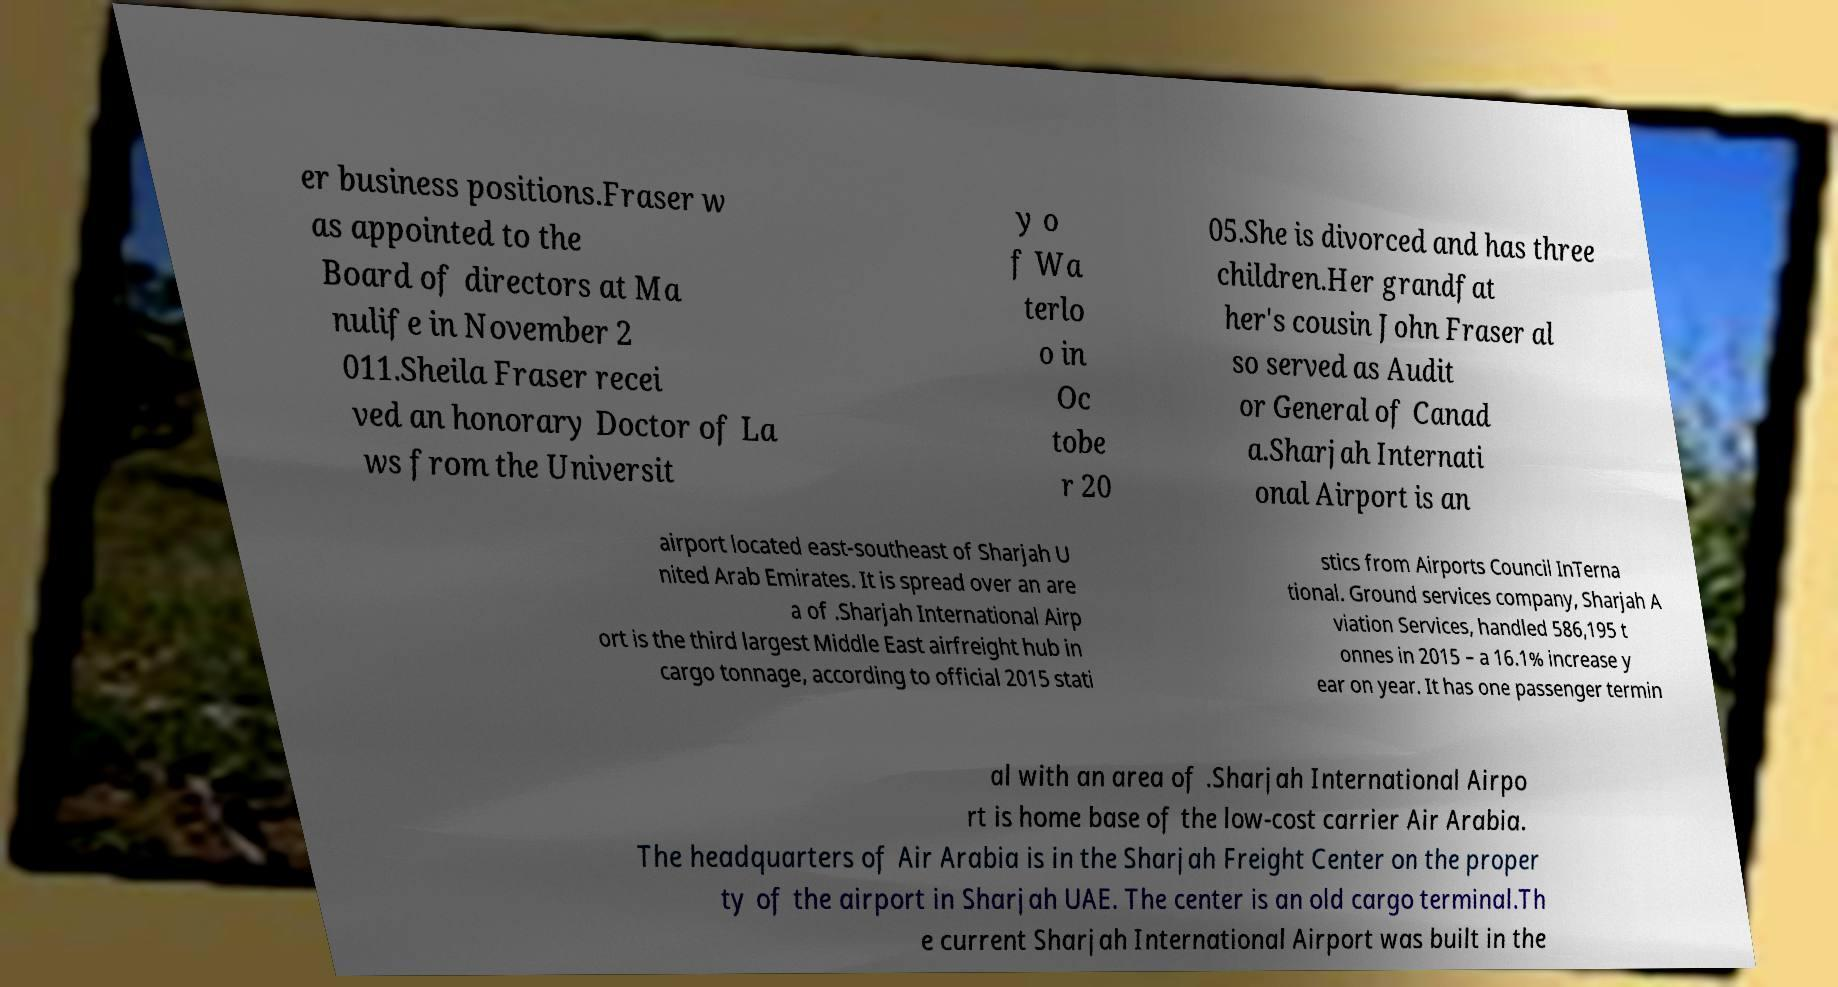Can you read and provide the text displayed in the image?This photo seems to have some interesting text. Can you extract and type it out for me? er business positions.Fraser w as appointed to the Board of directors at Ma nulife in November 2 011.Sheila Fraser recei ved an honorary Doctor of La ws from the Universit y o f Wa terlo o in Oc tobe r 20 05.She is divorced and has three children.Her grandfat her's cousin John Fraser al so served as Audit or General of Canad a.Sharjah Internati onal Airport is an airport located east-southeast of Sharjah U nited Arab Emirates. It is spread over an are a of .Sharjah International Airp ort is the third largest Middle East airfreight hub in cargo tonnage, according to official 2015 stati stics from Airports Council InTerna tional. Ground services company, Sharjah A viation Services, handled 586,195 t onnes in 2015 – a 16.1% increase y ear on year. It has one passenger termin al with an area of .Sharjah International Airpo rt is home base of the low-cost carrier Air Arabia. The headquarters of Air Arabia is in the Sharjah Freight Center on the proper ty of the airport in Sharjah UAE. The center is an old cargo terminal.Th e current Sharjah International Airport was built in the 